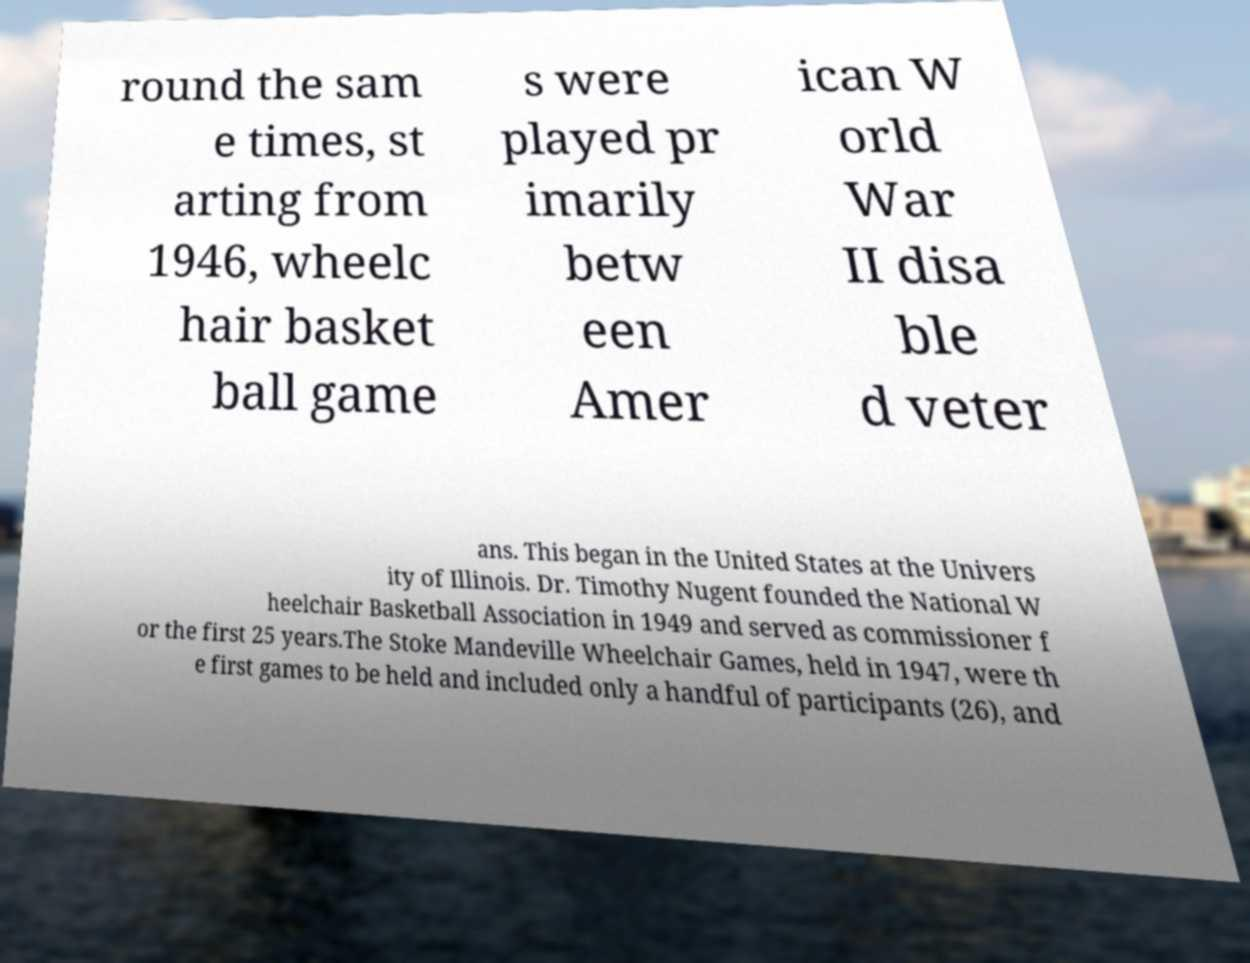Can you accurately transcribe the text from the provided image for me? round the sam e times, st arting from 1946, wheelc hair basket ball game s were played pr imarily betw een Amer ican W orld War II disa ble d veter ans. This began in the United States at the Univers ity of Illinois. Dr. Timothy Nugent founded the National W heelchair Basketball Association in 1949 and served as commissioner f or the first 25 years.The Stoke Mandeville Wheelchair Games, held in 1947, were th e first games to be held and included only a handful of participants (26), and 